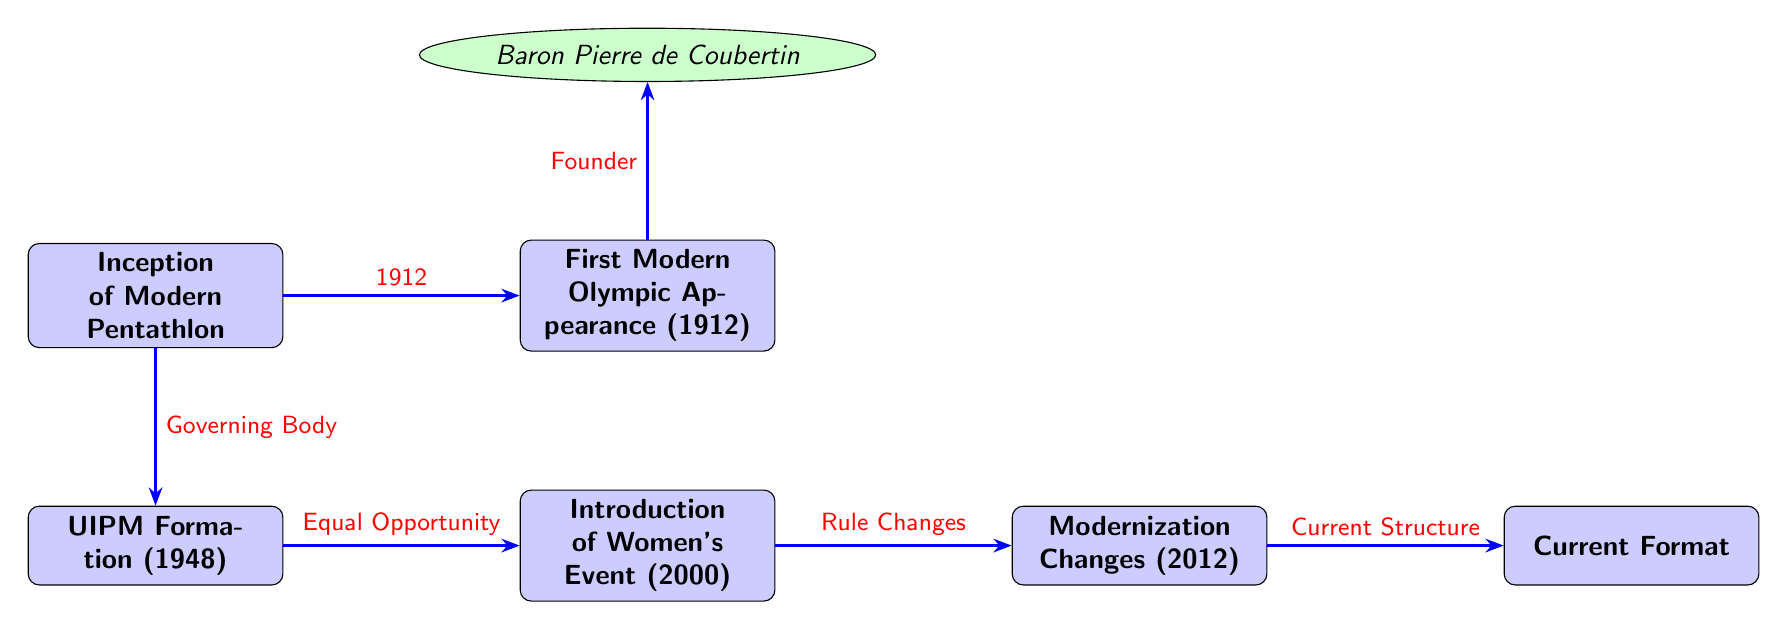What year did the Modern Pentathlon have its first Olympic appearance? The diagram shows a node labeled "First Modern Olympic Appearance (1912)," indicating the year of this event.
Answer: 1912 Who founded the Modern Pentathlon? The diagram indicates that Baron Pierre de Coubertin is linked to the "First Modern Olympic Appearance" node, identifying him as the founder.
Answer: Baron Pierre de Coubertin What organization was formed in 1948 related to Modern Pentathlon? The diagram directly shows a node that states "UIPM Formation (1948)," identifying the organization formed that year.
Answer: UIPM What milestone occurred in 2000? According to the diagram, the node titled "Introduction of Women's Event (2000)" specifies this important milestone in the history of Modern Pentathlon.
Answer: Introduction of Women's Event What event occurred due to equal opportunity as per the diagram? The arrow from the "UIPM Formation" node to the "Introduction of Women's Event" node signifies that the introduction of women’s events was a result of equal opportunities advocated by UIPM.
Answer: Women's Event What denotes the transition from previous rules to the current format? The diagram illustrates that the “Modernization Changes (2012)” node is linked to the “Current Format” node, indicating the transformation in rules leading to the present format.
Answer: Rule Changes How many key events are listed in the diagram? Counting the distinct events in the diagram, there are six prominent milestones linked by arrows.
Answer: Six What do the arrows in the diagram represent? The arrows connecting the nodes signify relationships or sequences of events in the historical evolution of Modern Pentathlon.
Answer: Relationships What marked the modernization of the sport in 2012? The “Modernization Changes (2012)” node indicates significant updates to the sport's structure or rules, marking its modernization phase.
Answer: Changes 